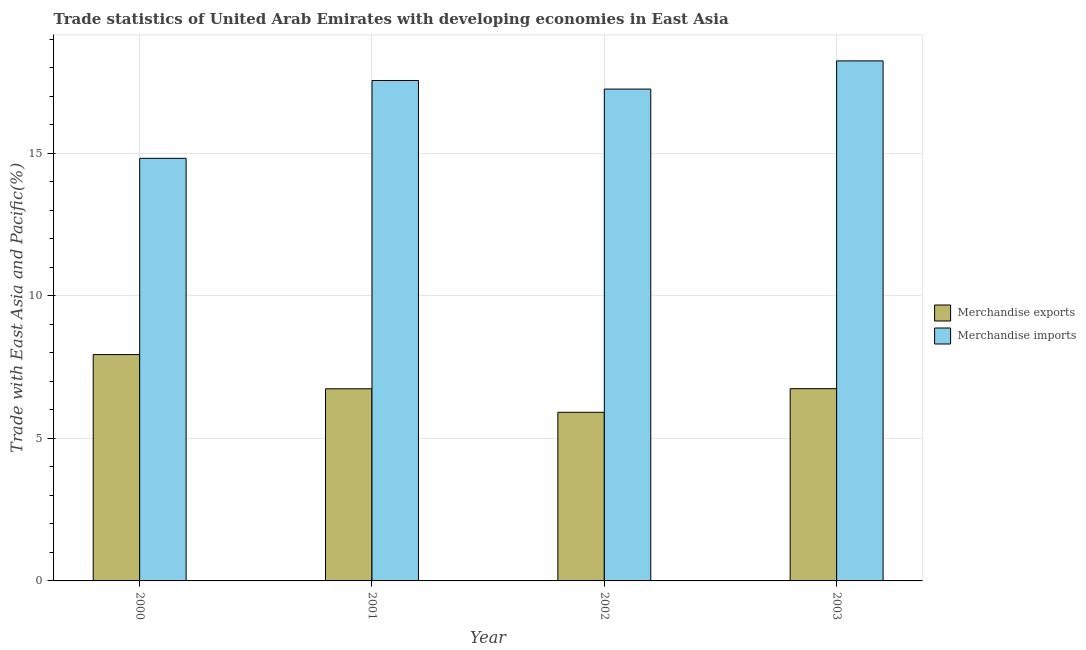How many different coloured bars are there?
Your response must be concise. 2. Are the number of bars per tick equal to the number of legend labels?
Give a very brief answer. Yes. How many bars are there on the 1st tick from the left?
Ensure brevity in your answer.  2. What is the label of the 1st group of bars from the left?
Keep it short and to the point. 2000. What is the merchandise imports in 2002?
Make the answer very short. 17.25. Across all years, what is the maximum merchandise imports?
Make the answer very short. 18.24. Across all years, what is the minimum merchandise imports?
Your answer should be very brief. 14.82. What is the total merchandise imports in the graph?
Keep it short and to the point. 67.86. What is the difference between the merchandise imports in 2002 and that in 2003?
Make the answer very short. -0.99. What is the difference between the merchandise imports in 2000 and the merchandise exports in 2001?
Ensure brevity in your answer.  -2.73. What is the average merchandise imports per year?
Your answer should be very brief. 16.96. In the year 2003, what is the difference between the merchandise exports and merchandise imports?
Your answer should be very brief. 0. What is the ratio of the merchandise exports in 2001 to that in 2002?
Offer a terse response. 1.14. Is the difference between the merchandise exports in 2001 and 2002 greater than the difference between the merchandise imports in 2001 and 2002?
Offer a very short reply. No. What is the difference between the highest and the second highest merchandise imports?
Ensure brevity in your answer.  0.69. What is the difference between the highest and the lowest merchandise imports?
Keep it short and to the point. 3.42. In how many years, is the merchandise imports greater than the average merchandise imports taken over all years?
Provide a succinct answer. 3. What does the 1st bar from the left in 2001 represents?
Give a very brief answer. Merchandise exports. Are all the bars in the graph horizontal?
Make the answer very short. No. How many years are there in the graph?
Your answer should be compact. 4. Does the graph contain grids?
Keep it short and to the point. Yes. How many legend labels are there?
Your response must be concise. 2. How are the legend labels stacked?
Provide a short and direct response. Vertical. What is the title of the graph?
Your answer should be compact. Trade statistics of United Arab Emirates with developing economies in East Asia. What is the label or title of the X-axis?
Your answer should be compact. Year. What is the label or title of the Y-axis?
Provide a short and direct response. Trade with East Asia and Pacific(%). What is the Trade with East Asia and Pacific(%) of Merchandise exports in 2000?
Provide a succinct answer. 7.94. What is the Trade with East Asia and Pacific(%) of Merchandise imports in 2000?
Make the answer very short. 14.82. What is the Trade with East Asia and Pacific(%) in Merchandise exports in 2001?
Make the answer very short. 6.74. What is the Trade with East Asia and Pacific(%) of Merchandise imports in 2001?
Ensure brevity in your answer.  17.55. What is the Trade with East Asia and Pacific(%) in Merchandise exports in 2002?
Offer a very short reply. 5.91. What is the Trade with East Asia and Pacific(%) of Merchandise imports in 2002?
Offer a very short reply. 17.25. What is the Trade with East Asia and Pacific(%) of Merchandise exports in 2003?
Your answer should be compact. 6.74. What is the Trade with East Asia and Pacific(%) of Merchandise imports in 2003?
Give a very brief answer. 18.24. Across all years, what is the maximum Trade with East Asia and Pacific(%) in Merchandise exports?
Provide a short and direct response. 7.94. Across all years, what is the maximum Trade with East Asia and Pacific(%) in Merchandise imports?
Your answer should be compact. 18.24. Across all years, what is the minimum Trade with East Asia and Pacific(%) in Merchandise exports?
Provide a succinct answer. 5.91. Across all years, what is the minimum Trade with East Asia and Pacific(%) in Merchandise imports?
Your answer should be very brief. 14.82. What is the total Trade with East Asia and Pacific(%) of Merchandise exports in the graph?
Your answer should be very brief. 27.33. What is the total Trade with East Asia and Pacific(%) in Merchandise imports in the graph?
Your answer should be very brief. 67.86. What is the difference between the Trade with East Asia and Pacific(%) of Merchandise exports in 2000 and that in 2001?
Ensure brevity in your answer.  1.2. What is the difference between the Trade with East Asia and Pacific(%) in Merchandise imports in 2000 and that in 2001?
Provide a short and direct response. -2.73. What is the difference between the Trade with East Asia and Pacific(%) in Merchandise exports in 2000 and that in 2002?
Your answer should be compact. 2.02. What is the difference between the Trade with East Asia and Pacific(%) of Merchandise imports in 2000 and that in 2002?
Provide a succinct answer. -2.43. What is the difference between the Trade with East Asia and Pacific(%) of Merchandise exports in 2000 and that in 2003?
Your answer should be very brief. 1.2. What is the difference between the Trade with East Asia and Pacific(%) of Merchandise imports in 2000 and that in 2003?
Give a very brief answer. -3.42. What is the difference between the Trade with East Asia and Pacific(%) in Merchandise exports in 2001 and that in 2002?
Your response must be concise. 0.82. What is the difference between the Trade with East Asia and Pacific(%) in Merchandise imports in 2001 and that in 2002?
Provide a succinct answer. 0.3. What is the difference between the Trade with East Asia and Pacific(%) in Merchandise exports in 2001 and that in 2003?
Provide a short and direct response. -0. What is the difference between the Trade with East Asia and Pacific(%) in Merchandise imports in 2001 and that in 2003?
Your answer should be very brief. -0.69. What is the difference between the Trade with East Asia and Pacific(%) in Merchandise exports in 2002 and that in 2003?
Provide a succinct answer. -0.83. What is the difference between the Trade with East Asia and Pacific(%) in Merchandise imports in 2002 and that in 2003?
Keep it short and to the point. -0.99. What is the difference between the Trade with East Asia and Pacific(%) of Merchandise exports in 2000 and the Trade with East Asia and Pacific(%) of Merchandise imports in 2001?
Your response must be concise. -9.61. What is the difference between the Trade with East Asia and Pacific(%) of Merchandise exports in 2000 and the Trade with East Asia and Pacific(%) of Merchandise imports in 2002?
Give a very brief answer. -9.31. What is the difference between the Trade with East Asia and Pacific(%) in Merchandise exports in 2000 and the Trade with East Asia and Pacific(%) in Merchandise imports in 2003?
Provide a succinct answer. -10.3. What is the difference between the Trade with East Asia and Pacific(%) in Merchandise exports in 2001 and the Trade with East Asia and Pacific(%) in Merchandise imports in 2002?
Provide a short and direct response. -10.51. What is the difference between the Trade with East Asia and Pacific(%) of Merchandise exports in 2001 and the Trade with East Asia and Pacific(%) of Merchandise imports in 2003?
Provide a short and direct response. -11.5. What is the difference between the Trade with East Asia and Pacific(%) in Merchandise exports in 2002 and the Trade with East Asia and Pacific(%) in Merchandise imports in 2003?
Make the answer very short. -12.32. What is the average Trade with East Asia and Pacific(%) of Merchandise exports per year?
Offer a very short reply. 6.83. What is the average Trade with East Asia and Pacific(%) of Merchandise imports per year?
Your answer should be very brief. 16.96. In the year 2000, what is the difference between the Trade with East Asia and Pacific(%) in Merchandise exports and Trade with East Asia and Pacific(%) in Merchandise imports?
Offer a very short reply. -6.88. In the year 2001, what is the difference between the Trade with East Asia and Pacific(%) of Merchandise exports and Trade with East Asia and Pacific(%) of Merchandise imports?
Ensure brevity in your answer.  -10.81. In the year 2002, what is the difference between the Trade with East Asia and Pacific(%) in Merchandise exports and Trade with East Asia and Pacific(%) in Merchandise imports?
Ensure brevity in your answer.  -11.34. In the year 2003, what is the difference between the Trade with East Asia and Pacific(%) in Merchandise exports and Trade with East Asia and Pacific(%) in Merchandise imports?
Keep it short and to the point. -11.5. What is the ratio of the Trade with East Asia and Pacific(%) in Merchandise exports in 2000 to that in 2001?
Provide a short and direct response. 1.18. What is the ratio of the Trade with East Asia and Pacific(%) of Merchandise imports in 2000 to that in 2001?
Keep it short and to the point. 0.84. What is the ratio of the Trade with East Asia and Pacific(%) in Merchandise exports in 2000 to that in 2002?
Keep it short and to the point. 1.34. What is the ratio of the Trade with East Asia and Pacific(%) of Merchandise imports in 2000 to that in 2002?
Provide a succinct answer. 0.86. What is the ratio of the Trade with East Asia and Pacific(%) of Merchandise exports in 2000 to that in 2003?
Provide a short and direct response. 1.18. What is the ratio of the Trade with East Asia and Pacific(%) in Merchandise imports in 2000 to that in 2003?
Ensure brevity in your answer.  0.81. What is the ratio of the Trade with East Asia and Pacific(%) of Merchandise exports in 2001 to that in 2002?
Make the answer very short. 1.14. What is the ratio of the Trade with East Asia and Pacific(%) in Merchandise imports in 2001 to that in 2002?
Ensure brevity in your answer.  1.02. What is the ratio of the Trade with East Asia and Pacific(%) of Merchandise exports in 2001 to that in 2003?
Provide a succinct answer. 1. What is the ratio of the Trade with East Asia and Pacific(%) in Merchandise imports in 2001 to that in 2003?
Keep it short and to the point. 0.96. What is the ratio of the Trade with East Asia and Pacific(%) of Merchandise exports in 2002 to that in 2003?
Your answer should be compact. 0.88. What is the ratio of the Trade with East Asia and Pacific(%) of Merchandise imports in 2002 to that in 2003?
Your answer should be very brief. 0.95. What is the difference between the highest and the second highest Trade with East Asia and Pacific(%) of Merchandise exports?
Your answer should be compact. 1.2. What is the difference between the highest and the second highest Trade with East Asia and Pacific(%) of Merchandise imports?
Your answer should be compact. 0.69. What is the difference between the highest and the lowest Trade with East Asia and Pacific(%) in Merchandise exports?
Give a very brief answer. 2.02. What is the difference between the highest and the lowest Trade with East Asia and Pacific(%) in Merchandise imports?
Make the answer very short. 3.42. 